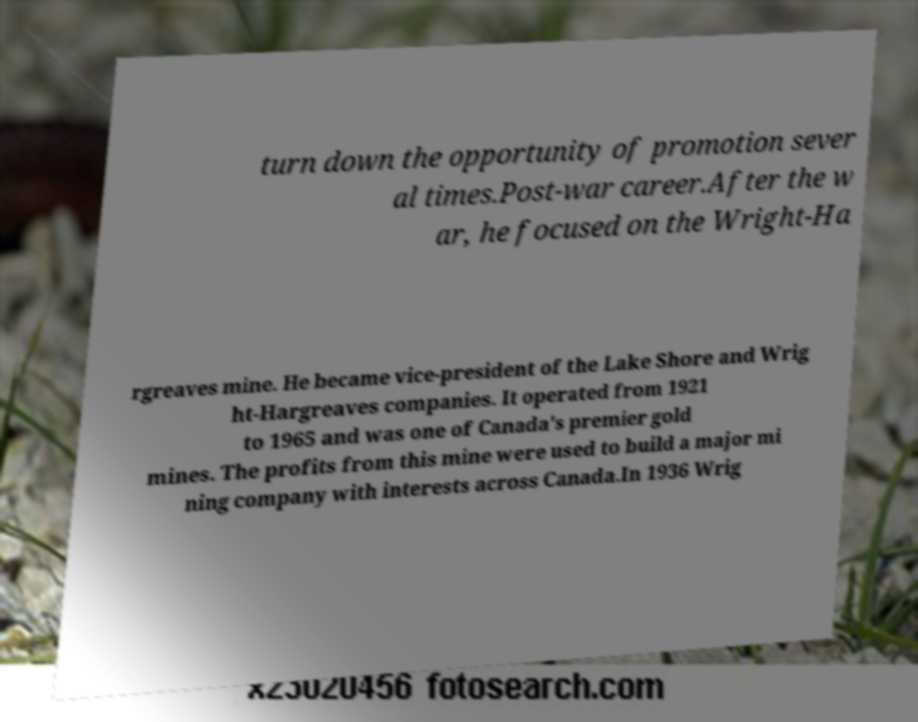I need the written content from this picture converted into text. Can you do that? turn down the opportunity of promotion sever al times.Post-war career.After the w ar, he focused on the Wright-Ha rgreaves mine. He became vice-president of the Lake Shore and Wrig ht-Hargreaves companies. It operated from 1921 to 1965 and was one of Canada's premier gold mines. The profits from this mine were used to build a major mi ning company with interests across Canada.In 1936 Wrig 